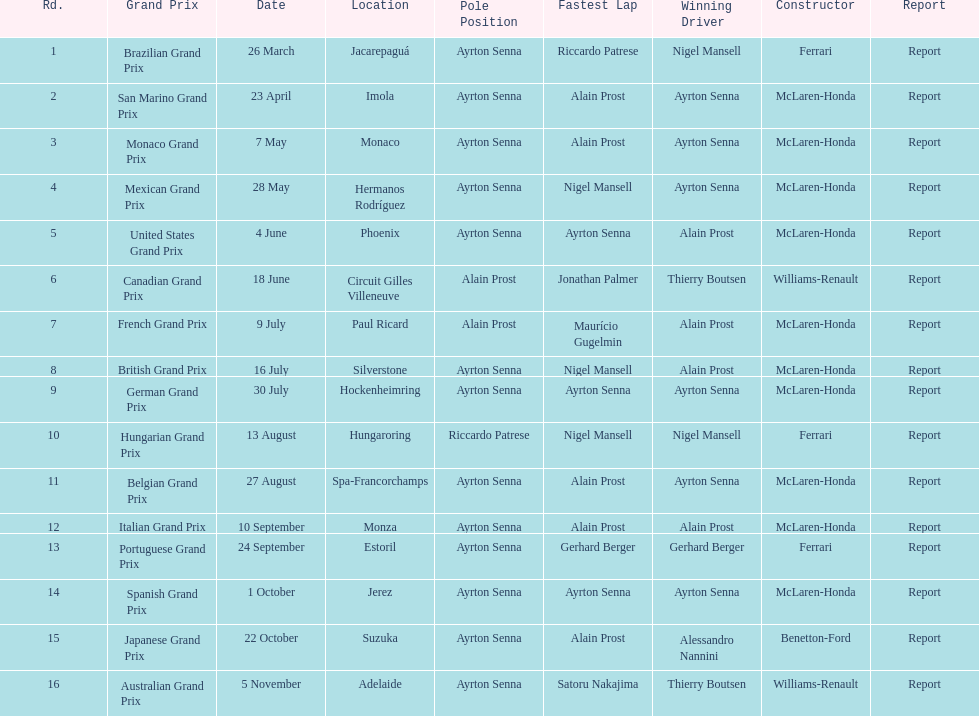What was the only grand prix to be won by benneton-ford? Japanese Grand Prix. 